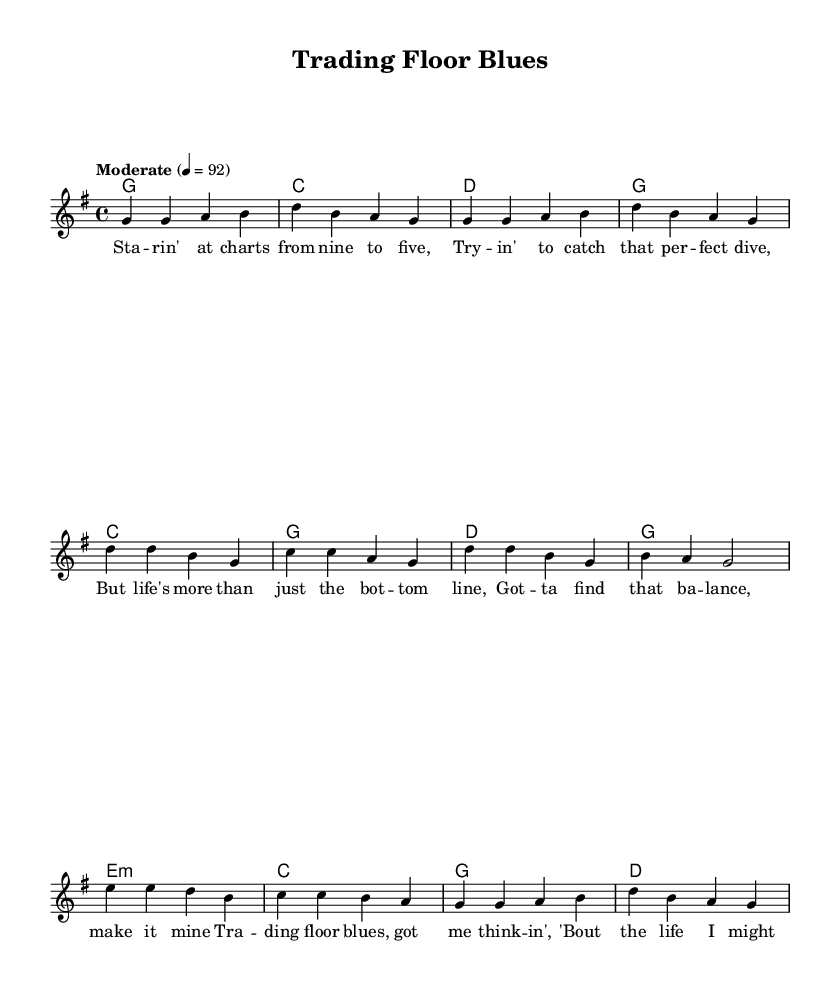What is the key signature of this music? The key signature is G major, which has one sharp (F#). It can be identified in the global setting at the beginning of the score.
Answer: G major What is the time signature of this music? The time signature is 4/4, indicated in the global section of the score. This shows that there are four beats per measure.
Answer: 4/4 What tempo is indicated for this music? The tempo is marked as "Moderate" at 4=92, which means there are 92 beats per minute at a moderate pace. This can be seen in the global section.
Answer: Moderate How many verses are there in the lyrics? There is one verse in the lyrics, which can be identified as "Verse One" labeled in the score before the chorus section.
Answer: One What is the primary theme of the lyrics? The primary theme reflects on balancing work and personal life, focusing on financial aspects and personal fulfillment. This theme can be interpreted from the overall content of the lyrics.
Answer: Balance How many chords are used in the verse section? There are four chords used in the verse section: G, C, D, and G. This can be counted from the chordmode section of the melody.
Answer: Four What musical form is primarily used in this piece? The musical form used is Verse-Chorus, as the structure shows a distinct verse followed by a chorus, then a bridge, typical of country music. This is evident from the arrangement of the sections.
Answer: Verse-Chorus 